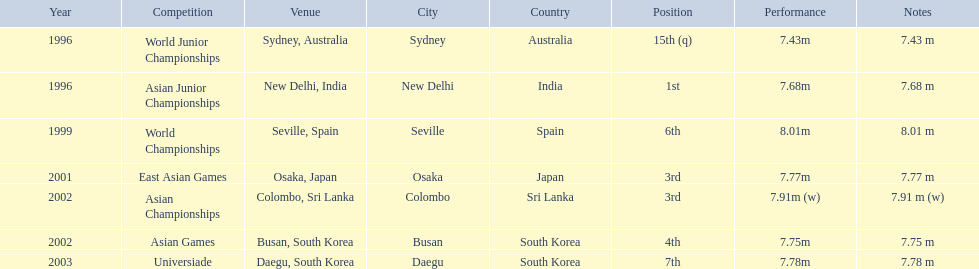What rankings has this competitor placed through the competitions? 15th (q), 1st, 6th, 3rd, 3rd, 4th, 7th. In which competition did the competitor place 1st? Asian Junior Championships. 